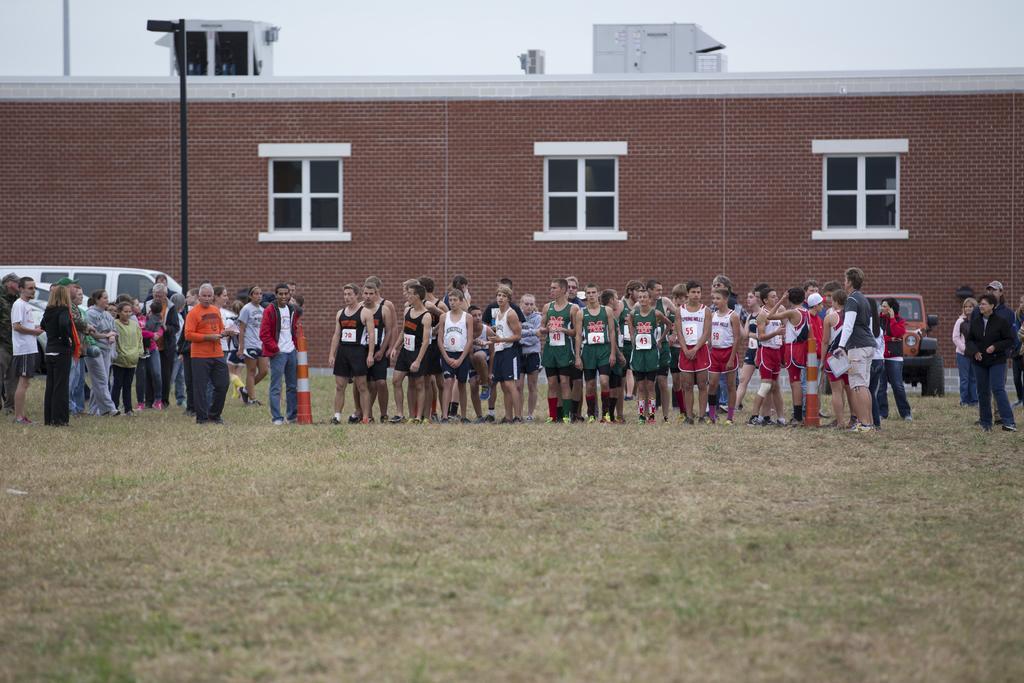Please provide a concise description of this image. In the center of the image we can see people standing and there are vehicles. In the background there is a building and we can see a pole. At the bottom there is grass. At the top there is sky. 